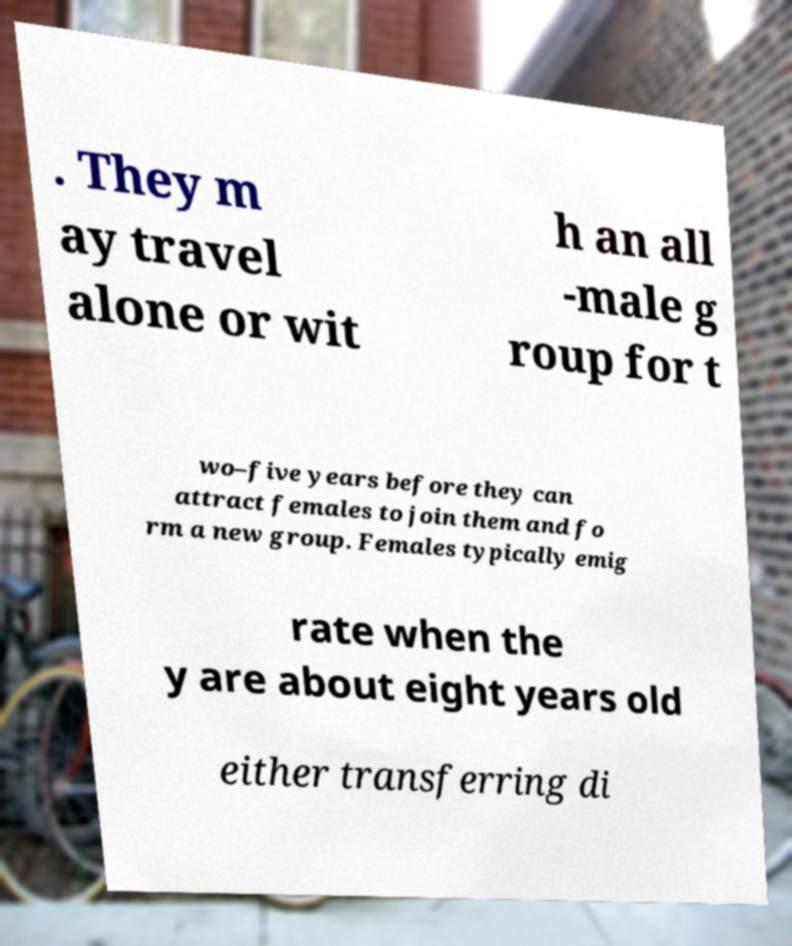Can you read and provide the text displayed in the image?This photo seems to have some interesting text. Can you extract and type it out for me? . They m ay travel alone or wit h an all -male g roup for t wo–five years before they can attract females to join them and fo rm a new group. Females typically emig rate when the y are about eight years old either transferring di 